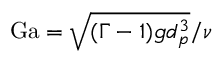Convert formula to latex. <formula><loc_0><loc_0><loc_500><loc_500>G a = \sqrt { ( \Gamma - 1 ) g d _ { p } ^ { 3 } } / \nu</formula> 